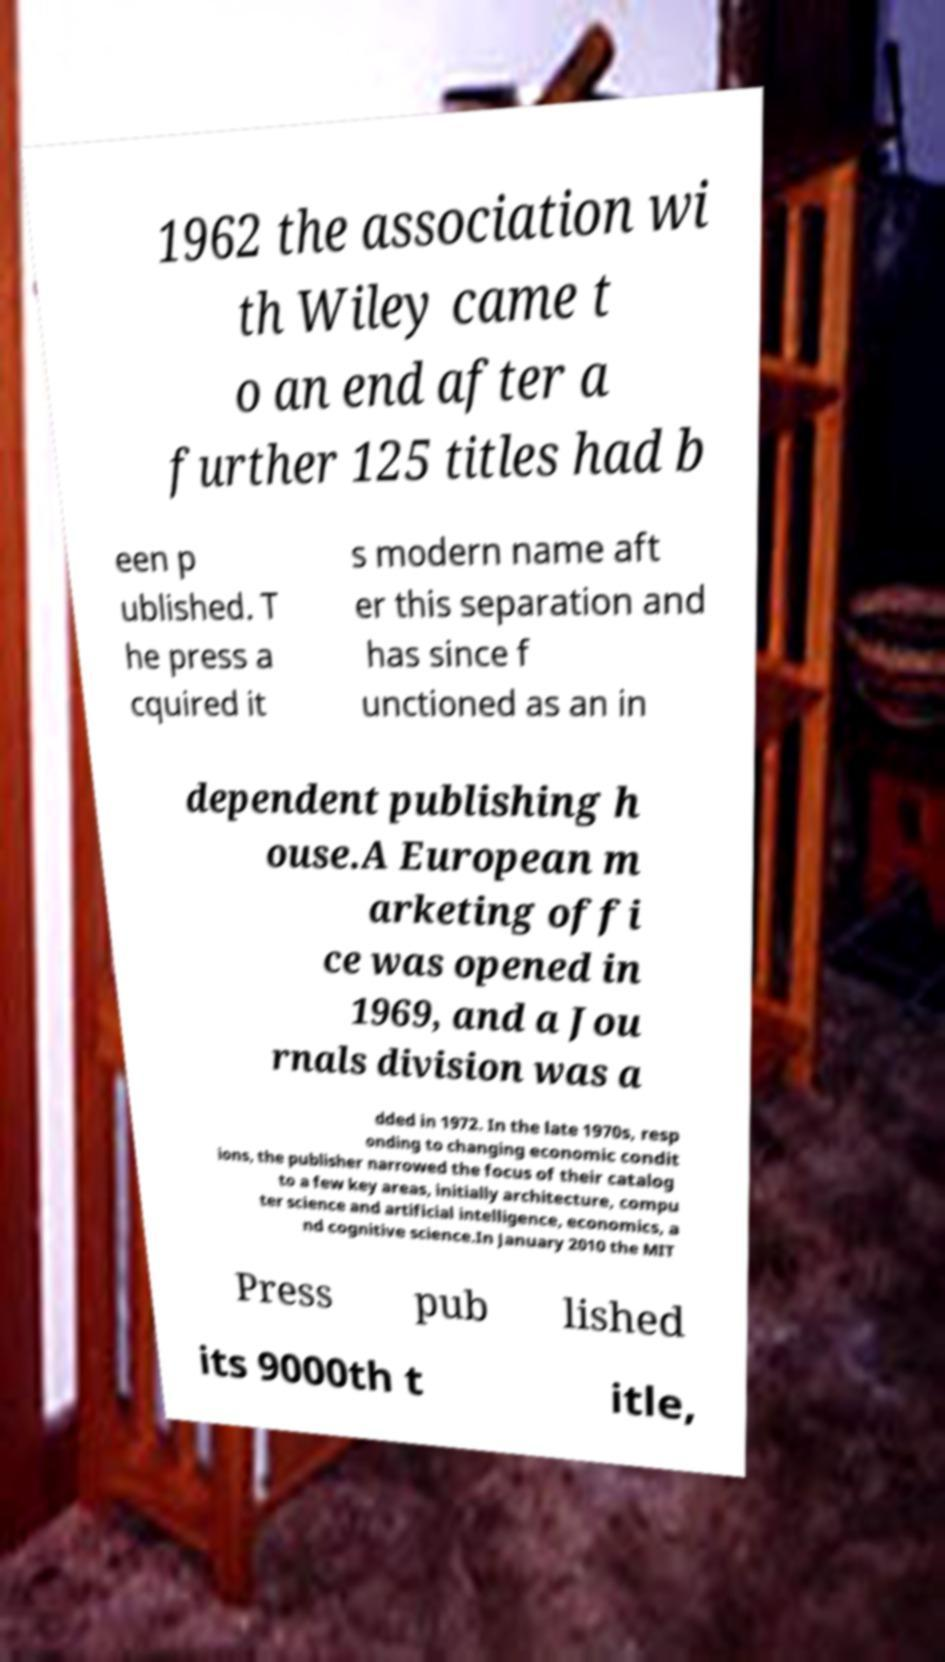Can you accurately transcribe the text from the provided image for me? 1962 the association wi th Wiley came t o an end after a further 125 titles had b een p ublished. T he press a cquired it s modern name aft er this separation and has since f unctioned as an in dependent publishing h ouse.A European m arketing offi ce was opened in 1969, and a Jou rnals division was a dded in 1972. In the late 1970s, resp onding to changing economic condit ions, the publisher narrowed the focus of their catalog to a few key areas, initially architecture, compu ter science and artificial intelligence, economics, a nd cognitive science.In January 2010 the MIT Press pub lished its 9000th t itle, 